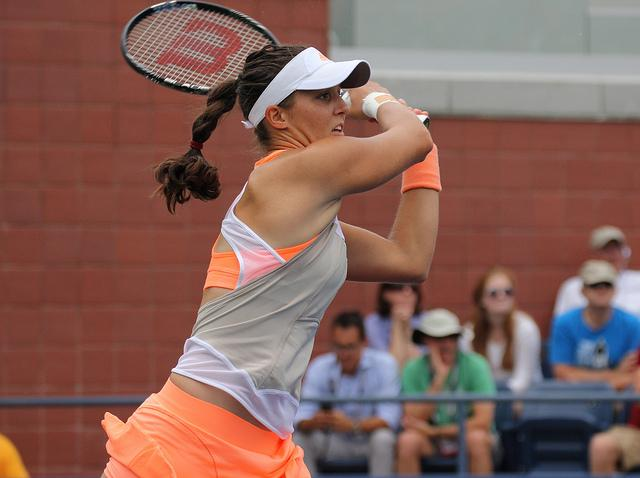What brand of tennis racket is she using to play? wilson 